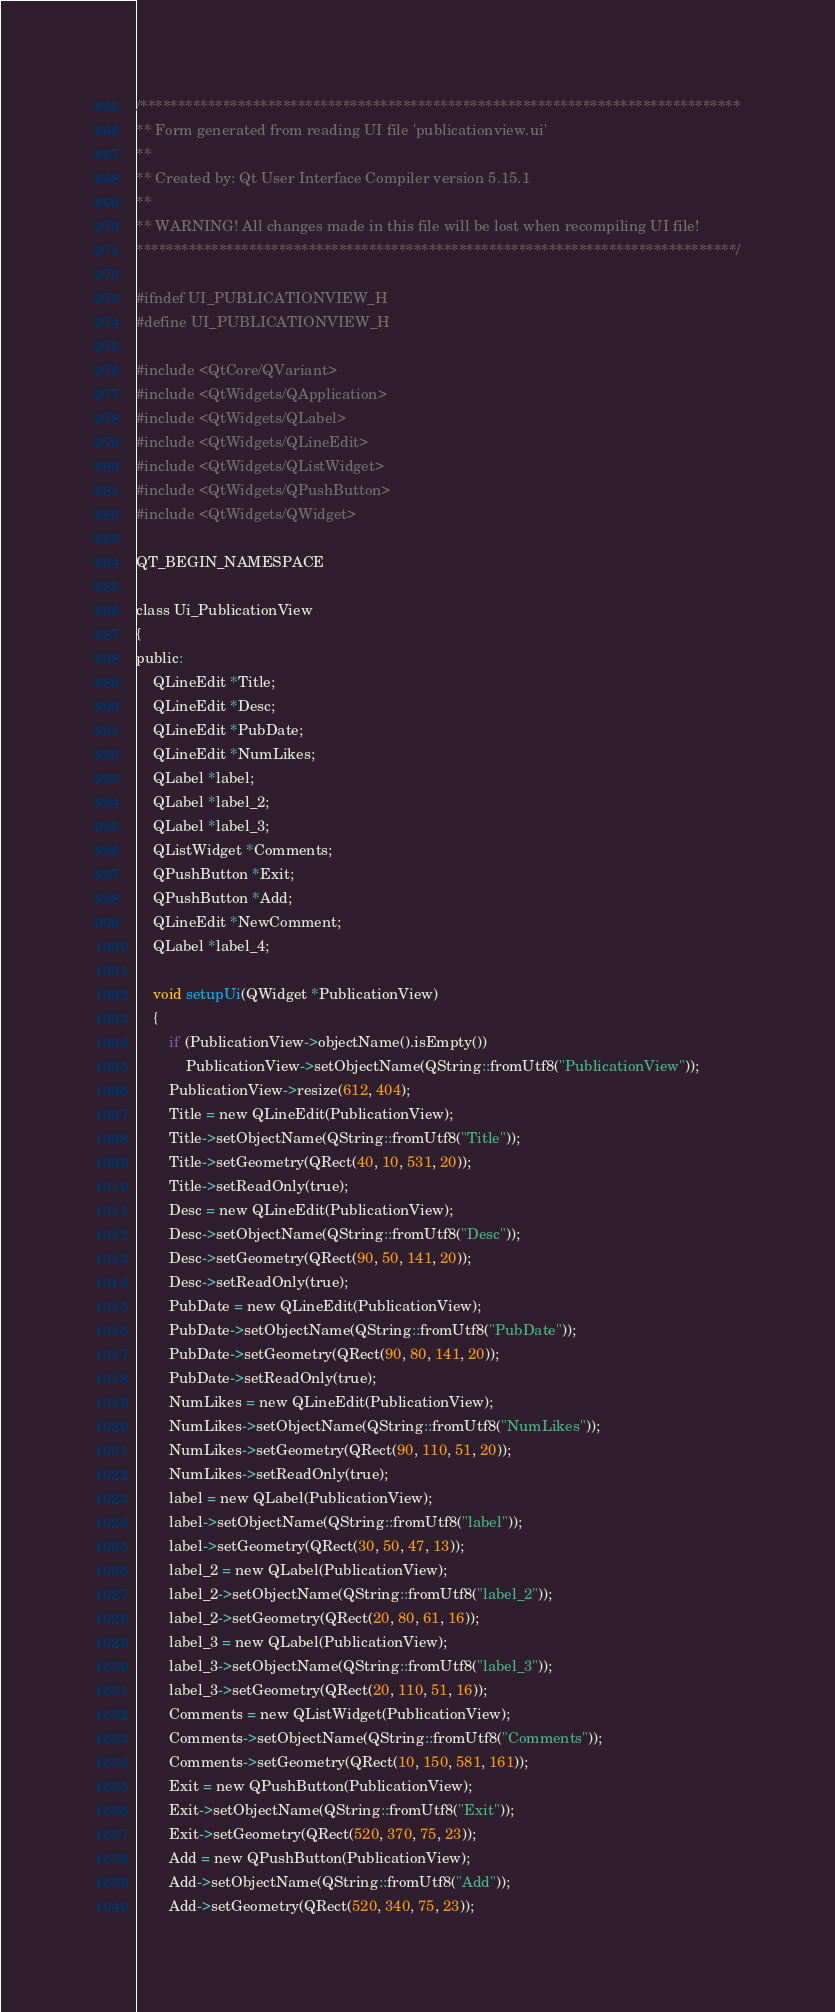Convert code to text. <code><loc_0><loc_0><loc_500><loc_500><_C_>/********************************************************************************
** Form generated from reading UI file 'publicationview.ui'
**
** Created by: Qt User Interface Compiler version 5.15.1
**
** WARNING! All changes made in this file will be lost when recompiling UI file!
********************************************************************************/

#ifndef UI_PUBLICATIONVIEW_H
#define UI_PUBLICATIONVIEW_H

#include <QtCore/QVariant>
#include <QtWidgets/QApplication>
#include <QtWidgets/QLabel>
#include <QtWidgets/QLineEdit>
#include <QtWidgets/QListWidget>
#include <QtWidgets/QPushButton>
#include <QtWidgets/QWidget>

QT_BEGIN_NAMESPACE

class Ui_PublicationView
{
public:
    QLineEdit *Title;
    QLineEdit *Desc;
    QLineEdit *PubDate;
    QLineEdit *NumLikes;
    QLabel *label;
    QLabel *label_2;
    QLabel *label_3;
    QListWidget *Comments;
    QPushButton *Exit;
    QPushButton *Add;
    QLineEdit *NewComment;
    QLabel *label_4;

    void setupUi(QWidget *PublicationView)
    {
        if (PublicationView->objectName().isEmpty())
            PublicationView->setObjectName(QString::fromUtf8("PublicationView"));
        PublicationView->resize(612, 404);
        Title = new QLineEdit(PublicationView);
        Title->setObjectName(QString::fromUtf8("Title"));
        Title->setGeometry(QRect(40, 10, 531, 20));
        Title->setReadOnly(true);
        Desc = new QLineEdit(PublicationView);
        Desc->setObjectName(QString::fromUtf8("Desc"));
        Desc->setGeometry(QRect(90, 50, 141, 20));
        Desc->setReadOnly(true);
        PubDate = new QLineEdit(PublicationView);
        PubDate->setObjectName(QString::fromUtf8("PubDate"));
        PubDate->setGeometry(QRect(90, 80, 141, 20));
        PubDate->setReadOnly(true);
        NumLikes = new QLineEdit(PublicationView);
        NumLikes->setObjectName(QString::fromUtf8("NumLikes"));
        NumLikes->setGeometry(QRect(90, 110, 51, 20));
        NumLikes->setReadOnly(true);
        label = new QLabel(PublicationView);
        label->setObjectName(QString::fromUtf8("label"));
        label->setGeometry(QRect(30, 50, 47, 13));
        label_2 = new QLabel(PublicationView);
        label_2->setObjectName(QString::fromUtf8("label_2"));
        label_2->setGeometry(QRect(20, 80, 61, 16));
        label_3 = new QLabel(PublicationView);
        label_3->setObjectName(QString::fromUtf8("label_3"));
        label_3->setGeometry(QRect(20, 110, 51, 16));
        Comments = new QListWidget(PublicationView);
        Comments->setObjectName(QString::fromUtf8("Comments"));
        Comments->setGeometry(QRect(10, 150, 581, 161));
        Exit = new QPushButton(PublicationView);
        Exit->setObjectName(QString::fromUtf8("Exit"));
        Exit->setGeometry(QRect(520, 370, 75, 23));
        Add = new QPushButton(PublicationView);
        Add->setObjectName(QString::fromUtf8("Add"));
        Add->setGeometry(QRect(520, 340, 75, 23));</code> 